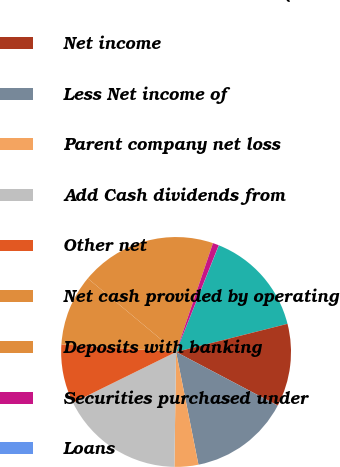Convert chart to OTSL. <chart><loc_0><loc_0><loc_500><loc_500><pie_chart><fcel>Year ended December 31 (in<fcel>Net income<fcel>Less Net income of<fcel>Parent company net loss<fcel>Add Cash dividends from<fcel>Other net<fcel>Net cash provided by operating<fcel>Deposits with banking<fcel>Securities purchased under<fcel>Loans<nl><fcel>14.99%<fcel>11.66%<fcel>14.16%<fcel>3.35%<fcel>17.49%<fcel>8.34%<fcel>10.0%<fcel>19.15%<fcel>0.85%<fcel>0.02%<nl></chart> 